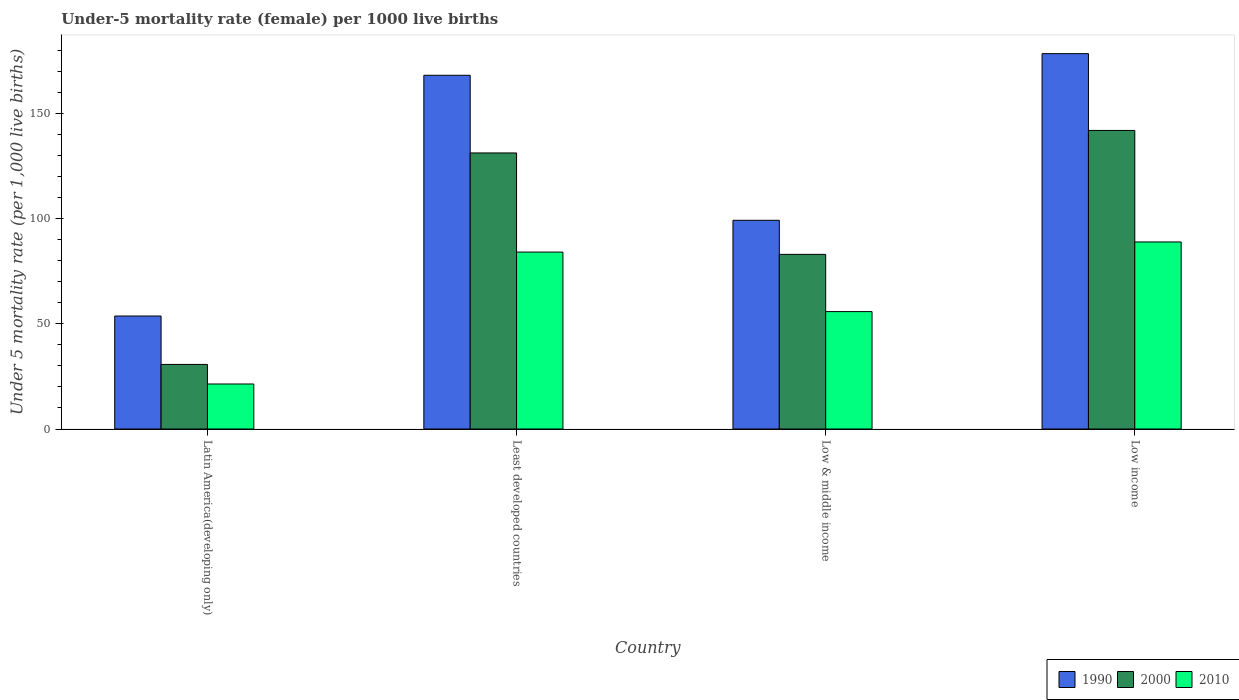What is the label of the 2nd group of bars from the left?
Provide a succinct answer. Least developed countries. In how many cases, is the number of bars for a given country not equal to the number of legend labels?
Offer a very short reply. 0. What is the under-five mortality rate in 2000 in Latin America(developing only)?
Your response must be concise. 30.7. Across all countries, what is the maximum under-five mortality rate in 1990?
Make the answer very short. 178.4. Across all countries, what is the minimum under-five mortality rate in 2000?
Your response must be concise. 30.7. In which country was the under-five mortality rate in 2010 minimum?
Give a very brief answer. Latin America(developing only). What is the total under-five mortality rate in 2010 in the graph?
Your response must be concise. 250.19. What is the difference between the under-five mortality rate in 2000 in Latin America(developing only) and that in Low & middle income?
Provide a short and direct response. -52.3. What is the difference between the under-five mortality rate in 2010 in Low & middle income and the under-five mortality rate in 1990 in Latin America(developing only)?
Your answer should be very brief. 2.1. What is the average under-five mortality rate in 2000 per country?
Your answer should be compact. 96.7. What is the difference between the under-five mortality rate of/in 2010 and under-five mortality rate of/in 2000 in Low income?
Provide a short and direct response. -53. What is the ratio of the under-five mortality rate in 2010 in Least developed countries to that in Low income?
Offer a very short reply. 0.95. Is the under-five mortality rate in 2000 in Least developed countries less than that in Low & middle income?
Offer a terse response. No. What is the difference between the highest and the second highest under-five mortality rate in 1990?
Ensure brevity in your answer.  -10.28. What is the difference between the highest and the lowest under-five mortality rate in 2010?
Your response must be concise. 67.5. Is the sum of the under-five mortality rate in 2000 in Latin America(developing only) and Low & middle income greater than the maximum under-five mortality rate in 1990 across all countries?
Your response must be concise. No. What does the 3rd bar from the right in Low & middle income represents?
Provide a short and direct response. 1990. How many bars are there?
Your answer should be compact. 12. What is the difference between two consecutive major ticks on the Y-axis?
Your answer should be very brief. 50. How are the legend labels stacked?
Keep it short and to the point. Horizontal. What is the title of the graph?
Offer a very short reply. Under-5 mortality rate (female) per 1000 live births. Does "1984" appear as one of the legend labels in the graph?
Ensure brevity in your answer.  No. What is the label or title of the Y-axis?
Provide a succinct answer. Under 5 mortality rate (per 1,0 live births). What is the Under 5 mortality rate (per 1,000 live births) in 1990 in Latin America(developing only)?
Ensure brevity in your answer.  53.7. What is the Under 5 mortality rate (per 1,000 live births) in 2000 in Latin America(developing only)?
Keep it short and to the point. 30.7. What is the Under 5 mortality rate (per 1,000 live births) in 2010 in Latin America(developing only)?
Keep it short and to the point. 21.4. What is the Under 5 mortality rate (per 1,000 live births) in 1990 in Least developed countries?
Provide a succinct answer. 168.12. What is the Under 5 mortality rate (per 1,000 live births) in 2000 in Least developed countries?
Your response must be concise. 131.2. What is the Under 5 mortality rate (per 1,000 live births) in 2010 in Least developed countries?
Keep it short and to the point. 84.09. What is the Under 5 mortality rate (per 1,000 live births) of 1990 in Low & middle income?
Your answer should be very brief. 99.2. What is the Under 5 mortality rate (per 1,000 live births) in 2000 in Low & middle income?
Offer a very short reply. 83. What is the Under 5 mortality rate (per 1,000 live births) of 2010 in Low & middle income?
Make the answer very short. 55.8. What is the Under 5 mortality rate (per 1,000 live births) of 1990 in Low income?
Offer a very short reply. 178.4. What is the Under 5 mortality rate (per 1,000 live births) in 2000 in Low income?
Make the answer very short. 141.9. What is the Under 5 mortality rate (per 1,000 live births) of 2010 in Low income?
Give a very brief answer. 88.9. Across all countries, what is the maximum Under 5 mortality rate (per 1,000 live births) in 1990?
Keep it short and to the point. 178.4. Across all countries, what is the maximum Under 5 mortality rate (per 1,000 live births) in 2000?
Give a very brief answer. 141.9. Across all countries, what is the maximum Under 5 mortality rate (per 1,000 live births) in 2010?
Your answer should be very brief. 88.9. Across all countries, what is the minimum Under 5 mortality rate (per 1,000 live births) of 1990?
Make the answer very short. 53.7. Across all countries, what is the minimum Under 5 mortality rate (per 1,000 live births) in 2000?
Your answer should be very brief. 30.7. Across all countries, what is the minimum Under 5 mortality rate (per 1,000 live births) of 2010?
Ensure brevity in your answer.  21.4. What is the total Under 5 mortality rate (per 1,000 live births) of 1990 in the graph?
Your response must be concise. 499.42. What is the total Under 5 mortality rate (per 1,000 live births) of 2000 in the graph?
Provide a short and direct response. 386.8. What is the total Under 5 mortality rate (per 1,000 live births) in 2010 in the graph?
Make the answer very short. 250.19. What is the difference between the Under 5 mortality rate (per 1,000 live births) of 1990 in Latin America(developing only) and that in Least developed countries?
Provide a succinct answer. -114.42. What is the difference between the Under 5 mortality rate (per 1,000 live births) of 2000 in Latin America(developing only) and that in Least developed countries?
Keep it short and to the point. -100.5. What is the difference between the Under 5 mortality rate (per 1,000 live births) of 2010 in Latin America(developing only) and that in Least developed countries?
Keep it short and to the point. -62.69. What is the difference between the Under 5 mortality rate (per 1,000 live births) of 1990 in Latin America(developing only) and that in Low & middle income?
Your answer should be compact. -45.5. What is the difference between the Under 5 mortality rate (per 1,000 live births) of 2000 in Latin America(developing only) and that in Low & middle income?
Make the answer very short. -52.3. What is the difference between the Under 5 mortality rate (per 1,000 live births) in 2010 in Latin America(developing only) and that in Low & middle income?
Give a very brief answer. -34.4. What is the difference between the Under 5 mortality rate (per 1,000 live births) of 1990 in Latin America(developing only) and that in Low income?
Ensure brevity in your answer.  -124.7. What is the difference between the Under 5 mortality rate (per 1,000 live births) in 2000 in Latin America(developing only) and that in Low income?
Offer a terse response. -111.2. What is the difference between the Under 5 mortality rate (per 1,000 live births) of 2010 in Latin America(developing only) and that in Low income?
Offer a very short reply. -67.5. What is the difference between the Under 5 mortality rate (per 1,000 live births) of 1990 in Least developed countries and that in Low & middle income?
Keep it short and to the point. 68.92. What is the difference between the Under 5 mortality rate (per 1,000 live births) of 2000 in Least developed countries and that in Low & middle income?
Ensure brevity in your answer.  48.2. What is the difference between the Under 5 mortality rate (per 1,000 live births) in 2010 in Least developed countries and that in Low & middle income?
Provide a succinct answer. 28.29. What is the difference between the Under 5 mortality rate (per 1,000 live births) of 1990 in Least developed countries and that in Low income?
Provide a short and direct response. -10.28. What is the difference between the Under 5 mortality rate (per 1,000 live births) in 2000 in Least developed countries and that in Low income?
Your response must be concise. -10.7. What is the difference between the Under 5 mortality rate (per 1,000 live births) of 2010 in Least developed countries and that in Low income?
Ensure brevity in your answer.  -4.81. What is the difference between the Under 5 mortality rate (per 1,000 live births) of 1990 in Low & middle income and that in Low income?
Provide a short and direct response. -79.2. What is the difference between the Under 5 mortality rate (per 1,000 live births) of 2000 in Low & middle income and that in Low income?
Offer a very short reply. -58.9. What is the difference between the Under 5 mortality rate (per 1,000 live births) of 2010 in Low & middle income and that in Low income?
Your answer should be very brief. -33.1. What is the difference between the Under 5 mortality rate (per 1,000 live births) of 1990 in Latin America(developing only) and the Under 5 mortality rate (per 1,000 live births) of 2000 in Least developed countries?
Your response must be concise. -77.5. What is the difference between the Under 5 mortality rate (per 1,000 live births) in 1990 in Latin America(developing only) and the Under 5 mortality rate (per 1,000 live births) in 2010 in Least developed countries?
Your answer should be very brief. -30.39. What is the difference between the Under 5 mortality rate (per 1,000 live births) of 2000 in Latin America(developing only) and the Under 5 mortality rate (per 1,000 live births) of 2010 in Least developed countries?
Your response must be concise. -53.39. What is the difference between the Under 5 mortality rate (per 1,000 live births) of 1990 in Latin America(developing only) and the Under 5 mortality rate (per 1,000 live births) of 2000 in Low & middle income?
Provide a succinct answer. -29.3. What is the difference between the Under 5 mortality rate (per 1,000 live births) of 2000 in Latin America(developing only) and the Under 5 mortality rate (per 1,000 live births) of 2010 in Low & middle income?
Offer a terse response. -25.1. What is the difference between the Under 5 mortality rate (per 1,000 live births) of 1990 in Latin America(developing only) and the Under 5 mortality rate (per 1,000 live births) of 2000 in Low income?
Provide a succinct answer. -88.2. What is the difference between the Under 5 mortality rate (per 1,000 live births) in 1990 in Latin America(developing only) and the Under 5 mortality rate (per 1,000 live births) in 2010 in Low income?
Make the answer very short. -35.2. What is the difference between the Under 5 mortality rate (per 1,000 live births) in 2000 in Latin America(developing only) and the Under 5 mortality rate (per 1,000 live births) in 2010 in Low income?
Your response must be concise. -58.2. What is the difference between the Under 5 mortality rate (per 1,000 live births) in 1990 in Least developed countries and the Under 5 mortality rate (per 1,000 live births) in 2000 in Low & middle income?
Provide a succinct answer. 85.12. What is the difference between the Under 5 mortality rate (per 1,000 live births) in 1990 in Least developed countries and the Under 5 mortality rate (per 1,000 live births) in 2010 in Low & middle income?
Your answer should be very brief. 112.32. What is the difference between the Under 5 mortality rate (per 1,000 live births) in 2000 in Least developed countries and the Under 5 mortality rate (per 1,000 live births) in 2010 in Low & middle income?
Provide a succinct answer. 75.4. What is the difference between the Under 5 mortality rate (per 1,000 live births) in 1990 in Least developed countries and the Under 5 mortality rate (per 1,000 live births) in 2000 in Low income?
Keep it short and to the point. 26.22. What is the difference between the Under 5 mortality rate (per 1,000 live births) in 1990 in Least developed countries and the Under 5 mortality rate (per 1,000 live births) in 2010 in Low income?
Keep it short and to the point. 79.22. What is the difference between the Under 5 mortality rate (per 1,000 live births) of 2000 in Least developed countries and the Under 5 mortality rate (per 1,000 live births) of 2010 in Low income?
Ensure brevity in your answer.  42.3. What is the difference between the Under 5 mortality rate (per 1,000 live births) of 1990 in Low & middle income and the Under 5 mortality rate (per 1,000 live births) of 2000 in Low income?
Ensure brevity in your answer.  -42.7. What is the difference between the Under 5 mortality rate (per 1,000 live births) in 1990 in Low & middle income and the Under 5 mortality rate (per 1,000 live births) in 2010 in Low income?
Make the answer very short. 10.3. What is the average Under 5 mortality rate (per 1,000 live births) of 1990 per country?
Provide a short and direct response. 124.86. What is the average Under 5 mortality rate (per 1,000 live births) of 2000 per country?
Ensure brevity in your answer.  96.7. What is the average Under 5 mortality rate (per 1,000 live births) in 2010 per country?
Offer a very short reply. 62.55. What is the difference between the Under 5 mortality rate (per 1,000 live births) of 1990 and Under 5 mortality rate (per 1,000 live births) of 2000 in Latin America(developing only)?
Give a very brief answer. 23. What is the difference between the Under 5 mortality rate (per 1,000 live births) of 1990 and Under 5 mortality rate (per 1,000 live births) of 2010 in Latin America(developing only)?
Offer a terse response. 32.3. What is the difference between the Under 5 mortality rate (per 1,000 live births) of 2000 and Under 5 mortality rate (per 1,000 live births) of 2010 in Latin America(developing only)?
Your response must be concise. 9.3. What is the difference between the Under 5 mortality rate (per 1,000 live births) in 1990 and Under 5 mortality rate (per 1,000 live births) in 2000 in Least developed countries?
Give a very brief answer. 36.92. What is the difference between the Under 5 mortality rate (per 1,000 live births) in 1990 and Under 5 mortality rate (per 1,000 live births) in 2010 in Least developed countries?
Your answer should be compact. 84.04. What is the difference between the Under 5 mortality rate (per 1,000 live births) of 2000 and Under 5 mortality rate (per 1,000 live births) of 2010 in Least developed countries?
Offer a very short reply. 47.12. What is the difference between the Under 5 mortality rate (per 1,000 live births) of 1990 and Under 5 mortality rate (per 1,000 live births) of 2010 in Low & middle income?
Keep it short and to the point. 43.4. What is the difference between the Under 5 mortality rate (per 1,000 live births) in 2000 and Under 5 mortality rate (per 1,000 live births) in 2010 in Low & middle income?
Provide a succinct answer. 27.2. What is the difference between the Under 5 mortality rate (per 1,000 live births) in 1990 and Under 5 mortality rate (per 1,000 live births) in 2000 in Low income?
Provide a succinct answer. 36.5. What is the difference between the Under 5 mortality rate (per 1,000 live births) of 1990 and Under 5 mortality rate (per 1,000 live births) of 2010 in Low income?
Offer a terse response. 89.5. What is the ratio of the Under 5 mortality rate (per 1,000 live births) in 1990 in Latin America(developing only) to that in Least developed countries?
Your response must be concise. 0.32. What is the ratio of the Under 5 mortality rate (per 1,000 live births) of 2000 in Latin America(developing only) to that in Least developed countries?
Your answer should be compact. 0.23. What is the ratio of the Under 5 mortality rate (per 1,000 live births) in 2010 in Latin America(developing only) to that in Least developed countries?
Offer a very short reply. 0.25. What is the ratio of the Under 5 mortality rate (per 1,000 live births) in 1990 in Latin America(developing only) to that in Low & middle income?
Your answer should be very brief. 0.54. What is the ratio of the Under 5 mortality rate (per 1,000 live births) in 2000 in Latin America(developing only) to that in Low & middle income?
Provide a short and direct response. 0.37. What is the ratio of the Under 5 mortality rate (per 1,000 live births) of 2010 in Latin America(developing only) to that in Low & middle income?
Your response must be concise. 0.38. What is the ratio of the Under 5 mortality rate (per 1,000 live births) in 1990 in Latin America(developing only) to that in Low income?
Ensure brevity in your answer.  0.3. What is the ratio of the Under 5 mortality rate (per 1,000 live births) in 2000 in Latin America(developing only) to that in Low income?
Ensure brevity in your answer.  0.22. What is the ratio of the Under 5 mortality rate (per 1,000 live births) of 2010 in Latin America(developing only) to that in Low income?
Ensure brevity in your answer.  0.24. What is the ratio of the Under 5 mortality rate (per 1,000 live births) in 1990 in Least developed countries to that in Low & middle income?
Your answer should be compact. 1.69. What is the ratio of the Under 5 mortality rate (per 1,000 live births) in 2000 in Least developed countries to that in Low & middle income?
Keep it short and to the point. 1.58. What is the ratio of the Under 5 mortality rate (per 1,000 live births) in 2010 in Least developed countries to that in Low & middle income?
Offer a terse response. 1.51. What is the ratio of the Under 5 mortality rate (per 1,000 live births) in 1990 in Least developed countries to that in Low income?
Offer a very short reply. 0.94. What is the ratio of the Under 5 mortality rate (per 1,000 live births) of 2000 in Least developed countries to that in Low income?
Your answer should be very brief. 0.92. What is the ratio of the Under 5 mortality rate (per 1,000 live births) of 2010 in Least developed countries to that in Low income?
Make the answer very short. 0.95. What is the ratio of the Under 5 mortality rate (per 1,000 live births) of 1990 in Low & middle income to that in Low income?
Your answer should be compact. 0.56. What is the ratio of the Under 5 mortality rate (per 1,000 live births) in 2000 in Low & middle income to that in Low income?
Ensure brevity in your answer.  0.58. What is the ratio of the Under 5 mortality rate (per 1,000 live births) in 2010 in Low & middle income to that in Low income?
Make the answer very short. 0.63. What is the difference between the highest and the second highest Under 5 mortality rate (per 1,000 live births) in 1990?
Provide a succinct answer. 10.28. What is the difference between the highest and the second highest Under 5 mortality rate (per 1,000 live births) of 2000?
Provide a succinct answer. 10.7. What is the difference between the highest and the second highest Under 5 mortality rate (per 1,000 live births) in 2010?
Ensure brevity in your answer.  4.81. What is the difference between the highest and the lowest Under 5 mortality rate (per 1,000 live births) in 1990?
Your answer should be compact. 124.7. What is the difference between the highest and the lowest Under 5 mortality rate (per 1,000 live births) in 2000?
Ensure brevity in your answer.  111.2. What is the difference between the highest and the lowest Under 5 mortality rate (per 1,000 live births) of 2010?
Offer a terse response. 67.5. 